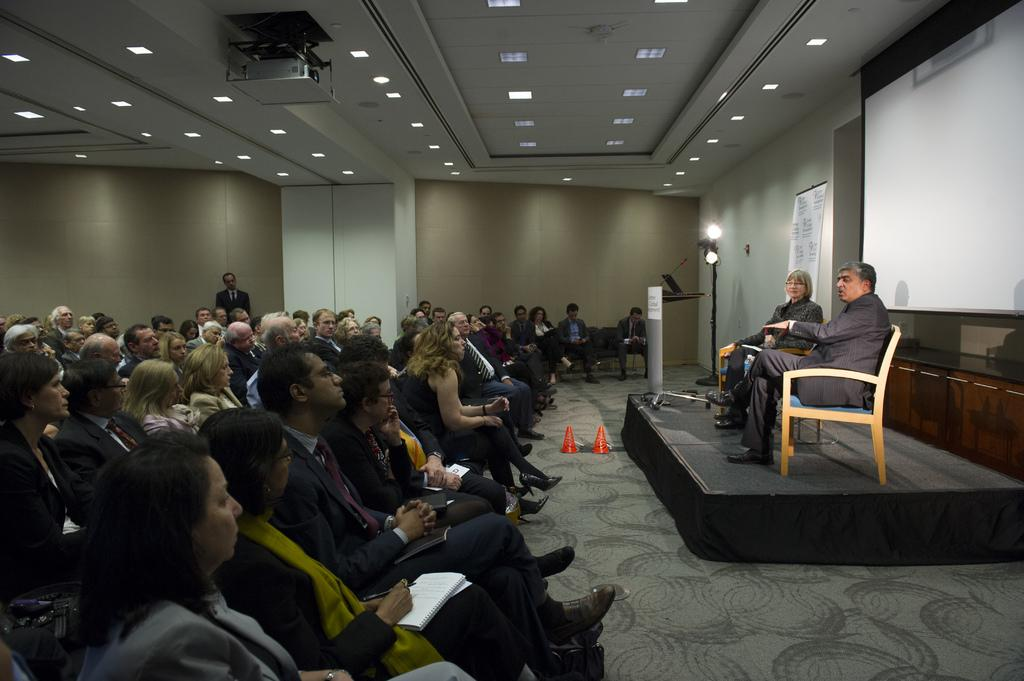How many people are visible in the image? There are many people sitting in the image. Can you describe the person in the background? There is a person standing in the background of the image. What can be seen behind the people in the image? There is a wall, a projector, and lights attached to the ceiling in the background of the image. How many trucks are parked near the sea in the image? There is no sea or trucks present in the image. 